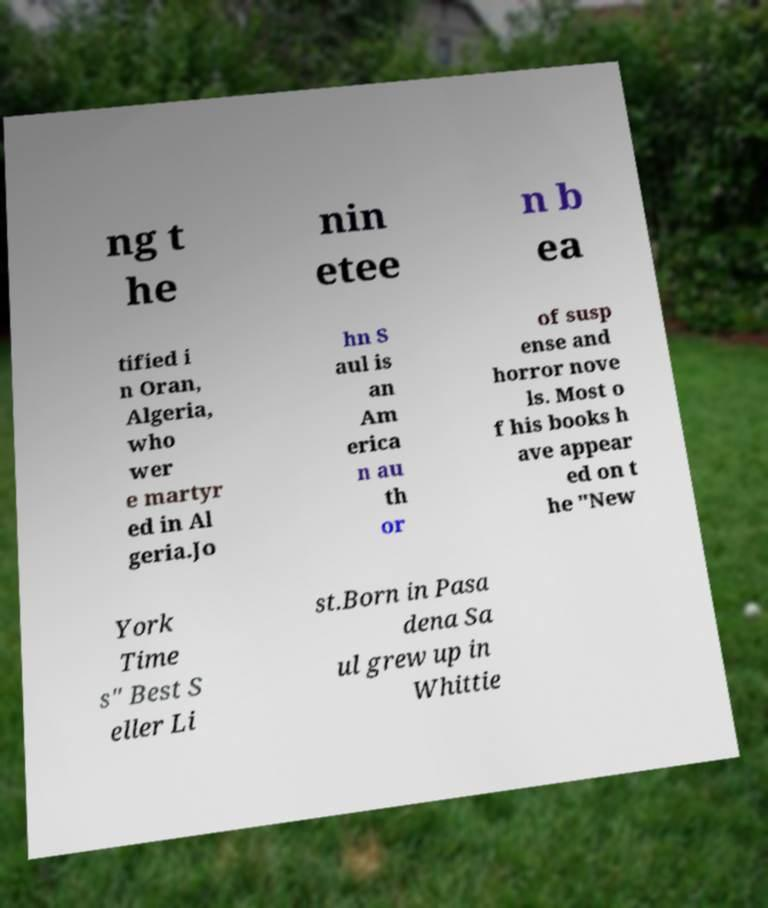Can you read and provide the text displayed in the image?This photo seems to have some interesting text. Can you extract and type it out for me? ng t he nin etee n b ea tified i n Oran, Algeria, who wer e martyr ed in Al geria.Jo hn S aul is an Am erica n au th or of susp ense and horror nove ls. Most o f his books h ave appear ed on t he "New York Time s" Best S eller Li st.Born in Pasa dena Sa ul grew up in Whittie 